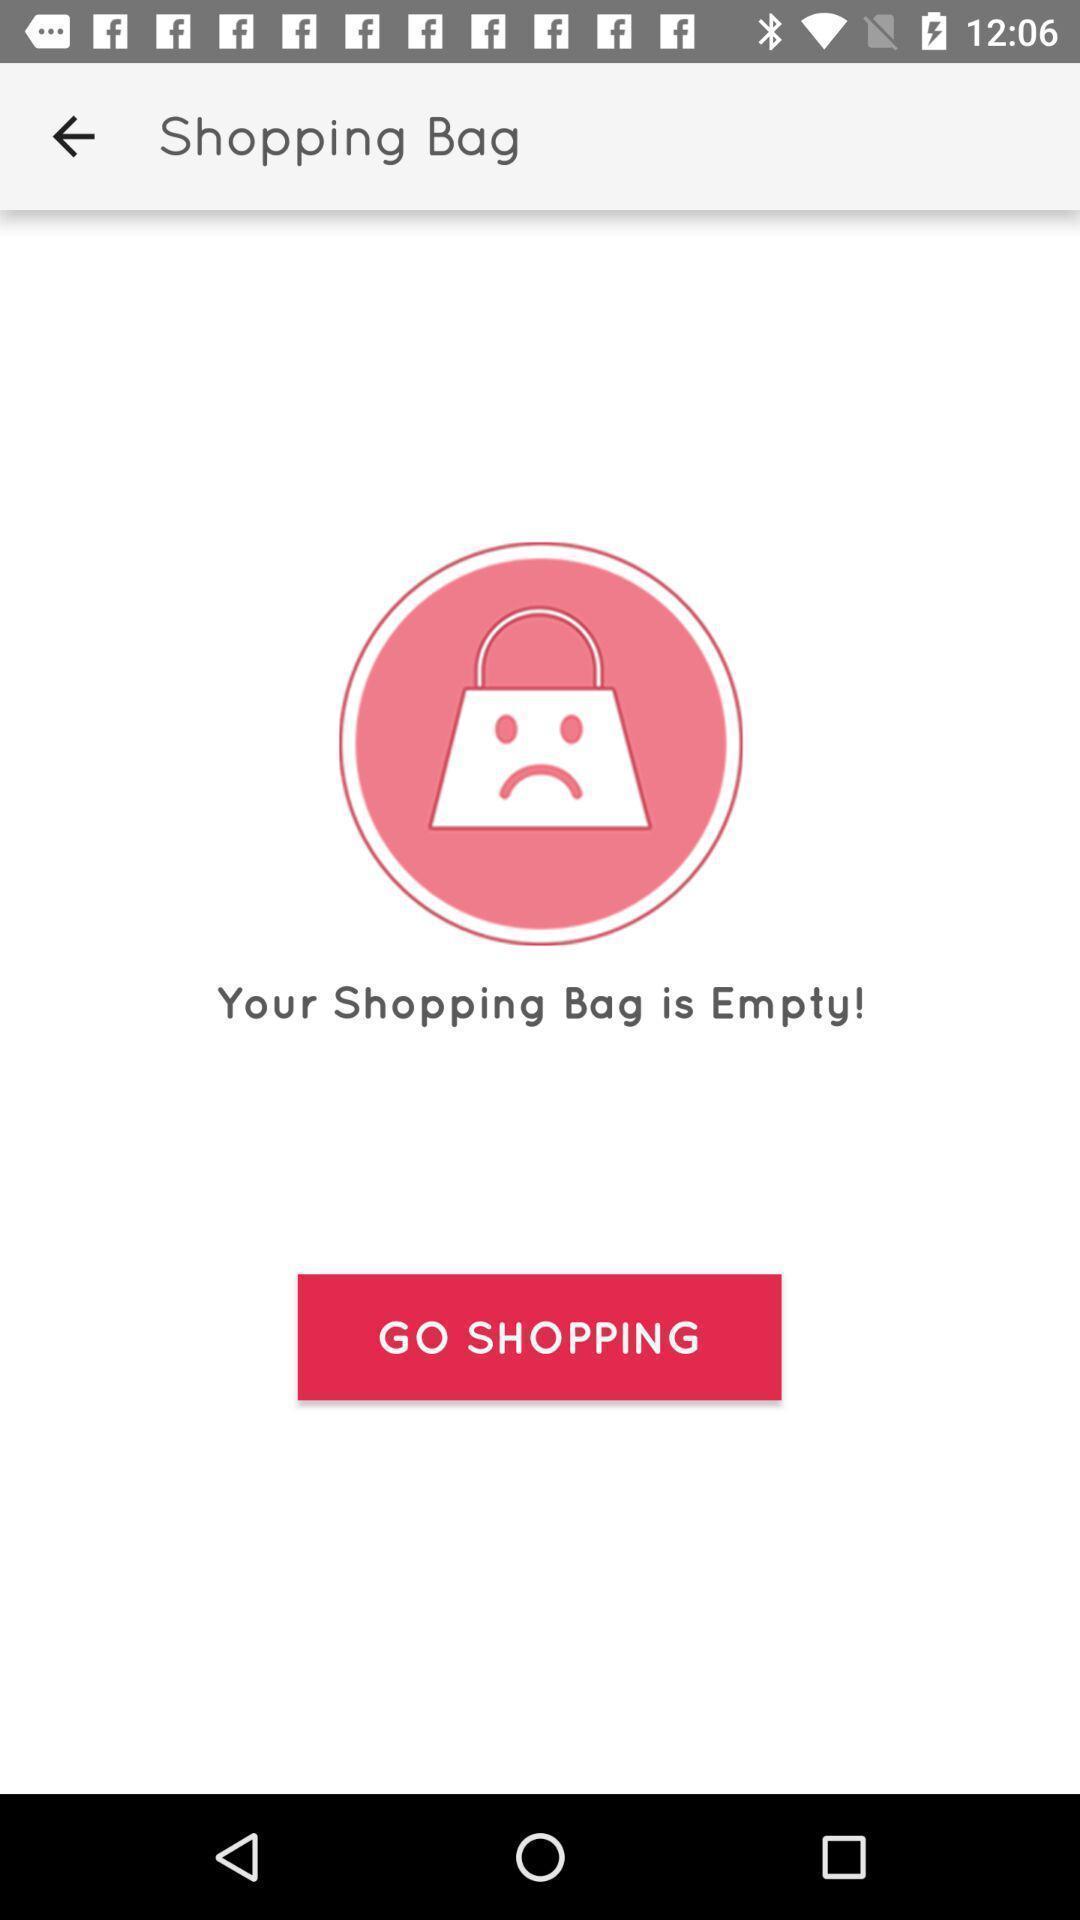Provide a description of this screenshot. Shopping bag page in a online beauty products app. 